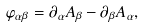<formula> <loc_0><loc_0><loc_500><loc_500>\varphi _ { \alpha \beta } = \partial _ { \alpha } A _ { \beta } - \partial _ { \beta } A _ { \alpha } ,</formula> 